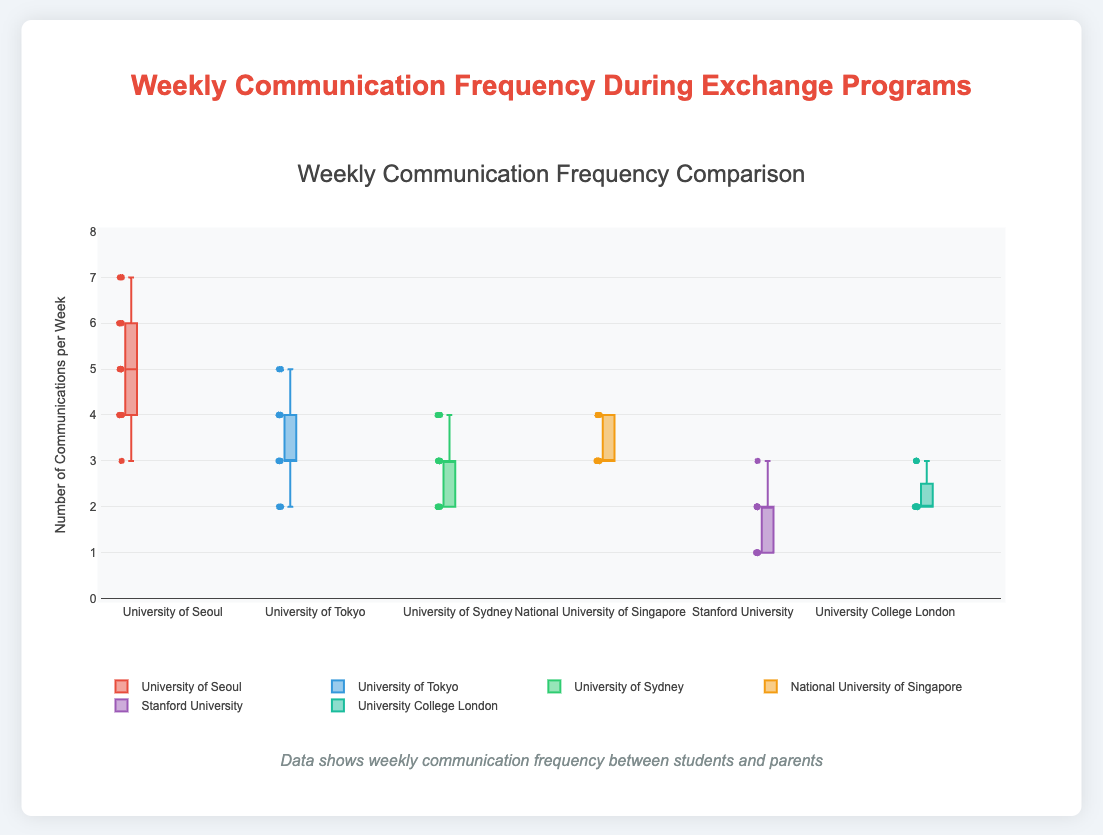What is the title of the figure? The title is typically at the top center of the figure, which visually stands out and provides a summary of what the figure is presenting.
Answer: Weekly Communication Frequency Comparison How many universities are compared in the figure? The universities are represented by different box plots, each labeled with the respective university's name. Count the number of unique labels.
Answer: Six What is the range for the y-axis values? The y-axis of the plot typically has a labeled scale that shows the minimum and maximum values it covers. Here, it ranges from 0 to 8.
Answer: 0 to 8 Which university has the highest median weekly communication frequency? To find the median, look for the line inside the box that divides it into two equal parts. Compare these lines across all universities.
Answer: University of Seoul Which university has the lowest maximum weekly communication frequency? The maximum is represented by the upper whisker end of the box plot. Compare the ends of the whiskers across all box plots.
Answer: Stanford University What are the quartiles for University of Seoul? A box plot's box is divided into quartiles. The bottom of the box is the first quartile (Q1), the line inside the box is the median, and the top of the box is the third quartile (Q3). Observe these positions for University of Seoul's box plot.
Answer: Q1 = 4, Median = 5, Q3 = 6 How does the interquartile range (IQR) of Stanford University compare to that of the National University of Singapore? The IQR is the difference between Q3 and Q1. Calculate the IQR for both universities and compare them.
Answer: Stanford University IQR = 2 - 1 = 1; NUS IQR = 4 - 3 = 1 Which universities have the same IQR? Calculate the IQR (Q3 - Q1) for each university and identify those with equal values.
Answer: University of Tokyo, University of Sydney, University College London, National University of Singapore, Stanford University (IQR = 1) Which university has the most spread in weekly communication frequency? The spread can be assessed by the range, which is the maximum minus the minimum value. Compare the range across all universities.
Answer: University of Seoul How frequently do students from University College London communicate per week on average? Although not directly depicted, you can approximate the mean value by analyzing the distribution of data points within the box plot while considering the central tendency around the median and the quartiles.
Answer: Approximately 2.33 